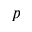Convert formula to latex. <formula><loc_0><loc_0><loc_500><loc_500>p</formula> 